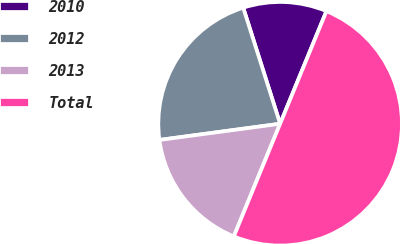Convert chart to OTSL. <chart><loc_0><loc_0><loc_500><loc_500><pie_chart><fcel>2010<fcel>2012<fcel>2013<fcel>Total<nl><fcel>11.11%<fcel>22.22%<fcel>16.67%<fcel>50.0%<nl></chart> 